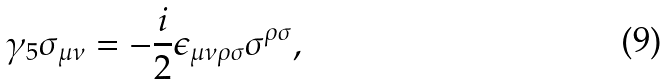<formula> <loc_0><loc_0><loc_500><loc_500>\gamma _ { 5 } \sigma _ { \mu \nu } = - \frac { i } { 2 } \epsilon _ { \mu \nu \rho \sigma } \sigma ^ { \rho \sigma } ,</formula> 